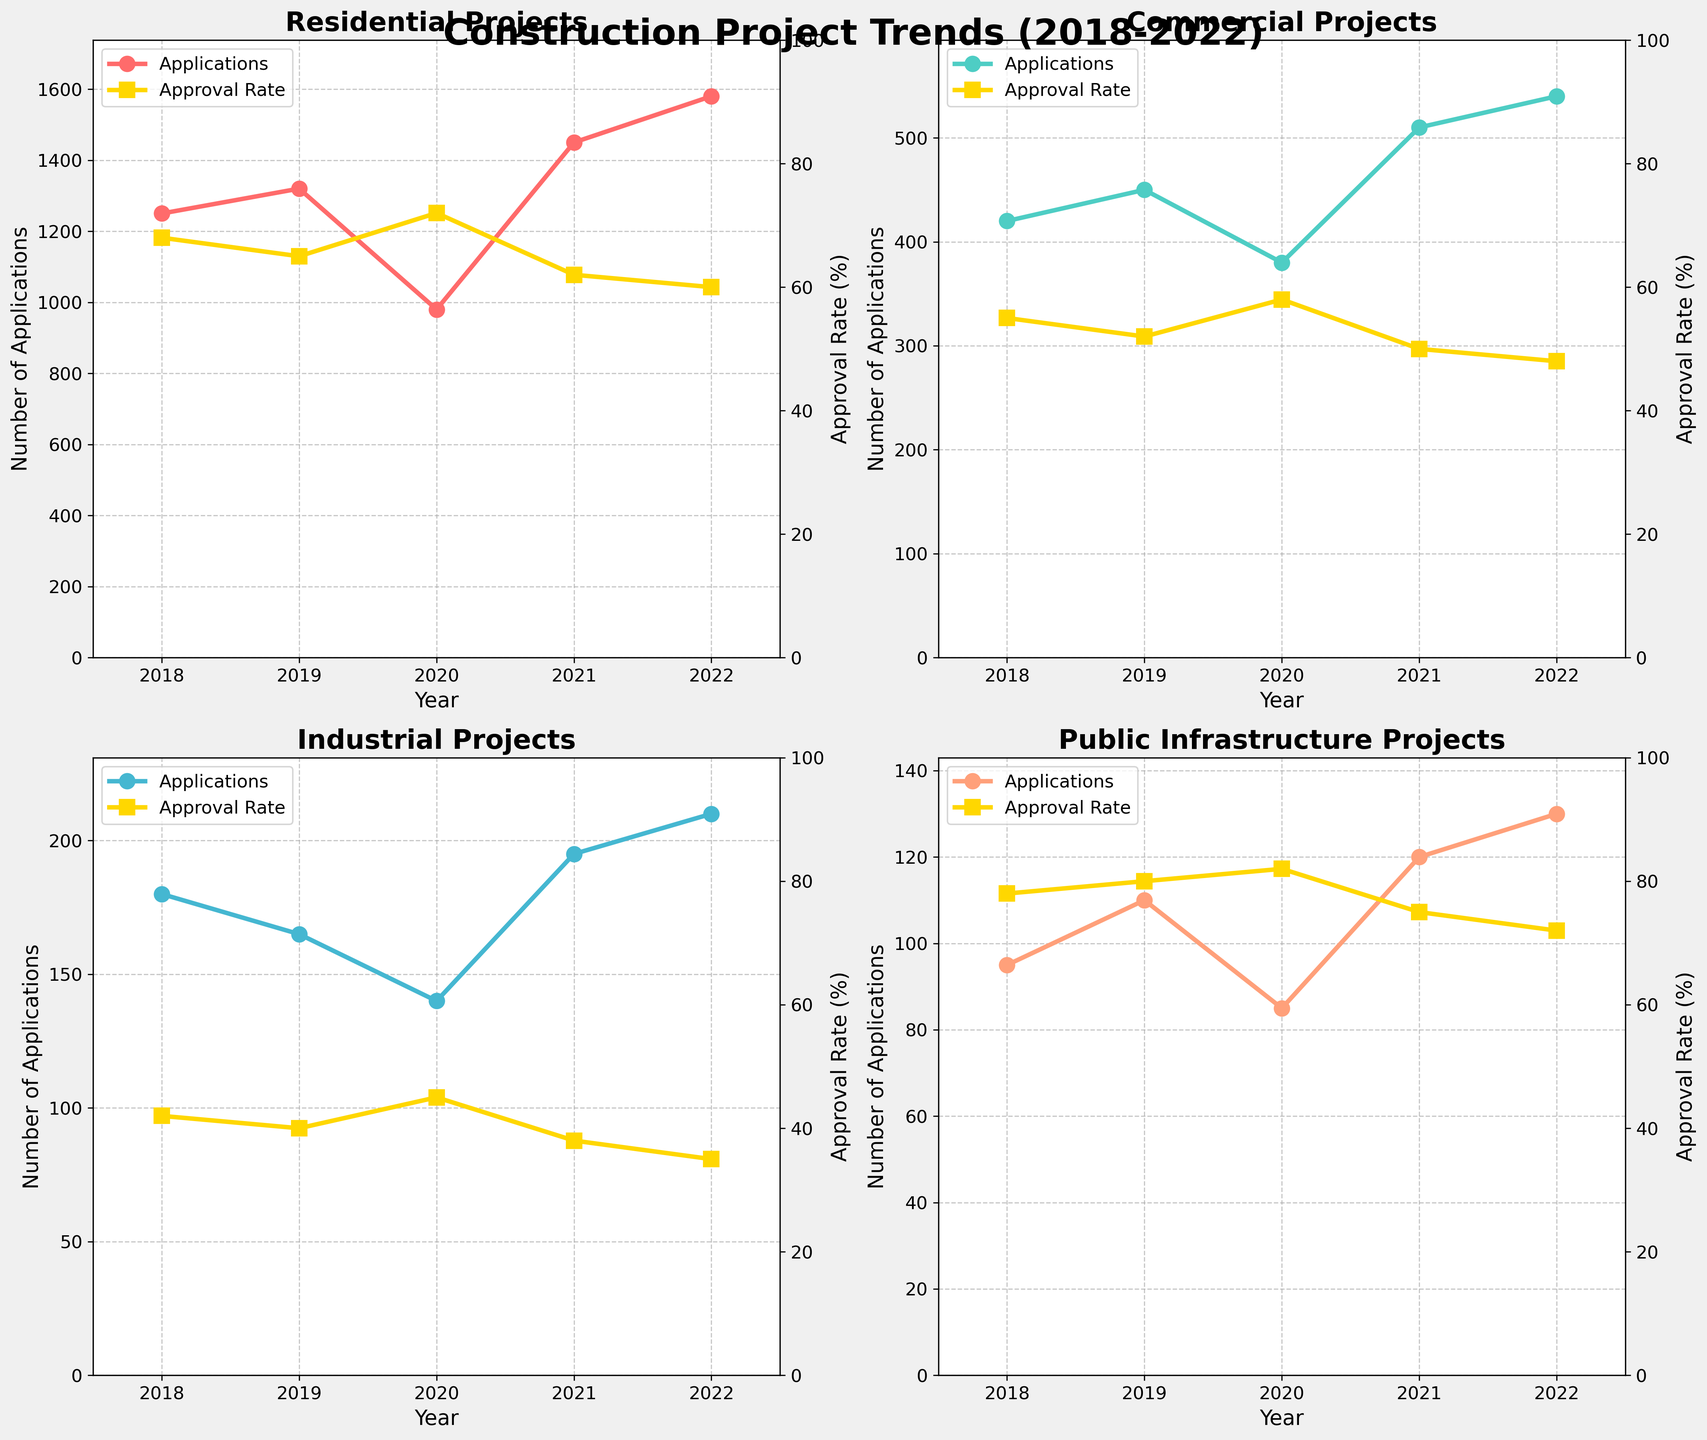What is the title of the figure? The title of the figure is displayed prominently at the top of the figure. It reads "Construction Project Trends (2018-2022)".
Answer: Construction Project Trends (2018-2022) How many different project types are displayed in the subplots? By looking at the subplots, each showing a different type of project, we can count that there are four project types: Residential, Commercial, Industrial, and Public Infrastructure.
Answer: Four Which project type had the highest number of applications in 2021? For 2021, we examine the subplots showing Residential, Commercial, Industrial, and Public Infrastructure plot individually. The Residential project type shows the highest number of applications, specifically around 1450.
Answer: Residential What is the trend of the approval rate for Industrial projects from 2018 to 2022? Observing the subplot for Industrial projects, the approval rate shows a decreasing trend from 42% in 2018 to 35% in 2022.
Answer: Decreasing Which year had the lowest application number for Commercial projects? By inspecting the subplot for Commercial projects, 2020 is the year with the lowest number of applications, which is 380 applications.
Answer: 2020 Compared to 2020, how much did the approval rate for Public Infrastructure projects change in 2021? The approval rate for Public Infrastructure projects in 2020 was 82%. In 2021, it decreased to 75%. The change is calculated as 82% - 75% = 7%.
Answer: Decreased by 7% What is the average approval rate for Residential projects from 2018 to 2022? Adding the approval rates for Residential projects for each year (68% + 65% + 72% + 62% + 60%) gives 327%. Dividing by 5 years, the average approval rate is 327% / 5 = 65.4%.
Answer: 65.4% Which project type had a relatively steady approval rate with slight variations over the years? Observing the subplots, the Public Infrastructure project subplot shows a relatively steady approval rate with slight variations ranging from 78% to 82%.
Answer: Public Infrastructure How did the number of applications for Residential projects change from 2019 to 2020? Examining the Residential project subplot, the number of applications decreased from 1320 in 2019 to 980 in 2020, showing a decrease of 340 applications.
Answer: Decreased by 340 